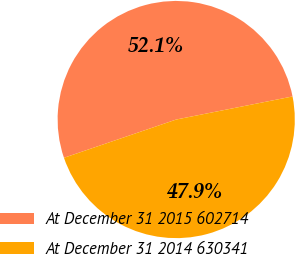<chart> <loc_0><loc_0><loc_500><loc_500><pie_chart><fcel>At December 31 2015 602714<fcel>At December 31 2014 630341<nl><fcel>52.11%<fcel>47.89%<nl></chart> 